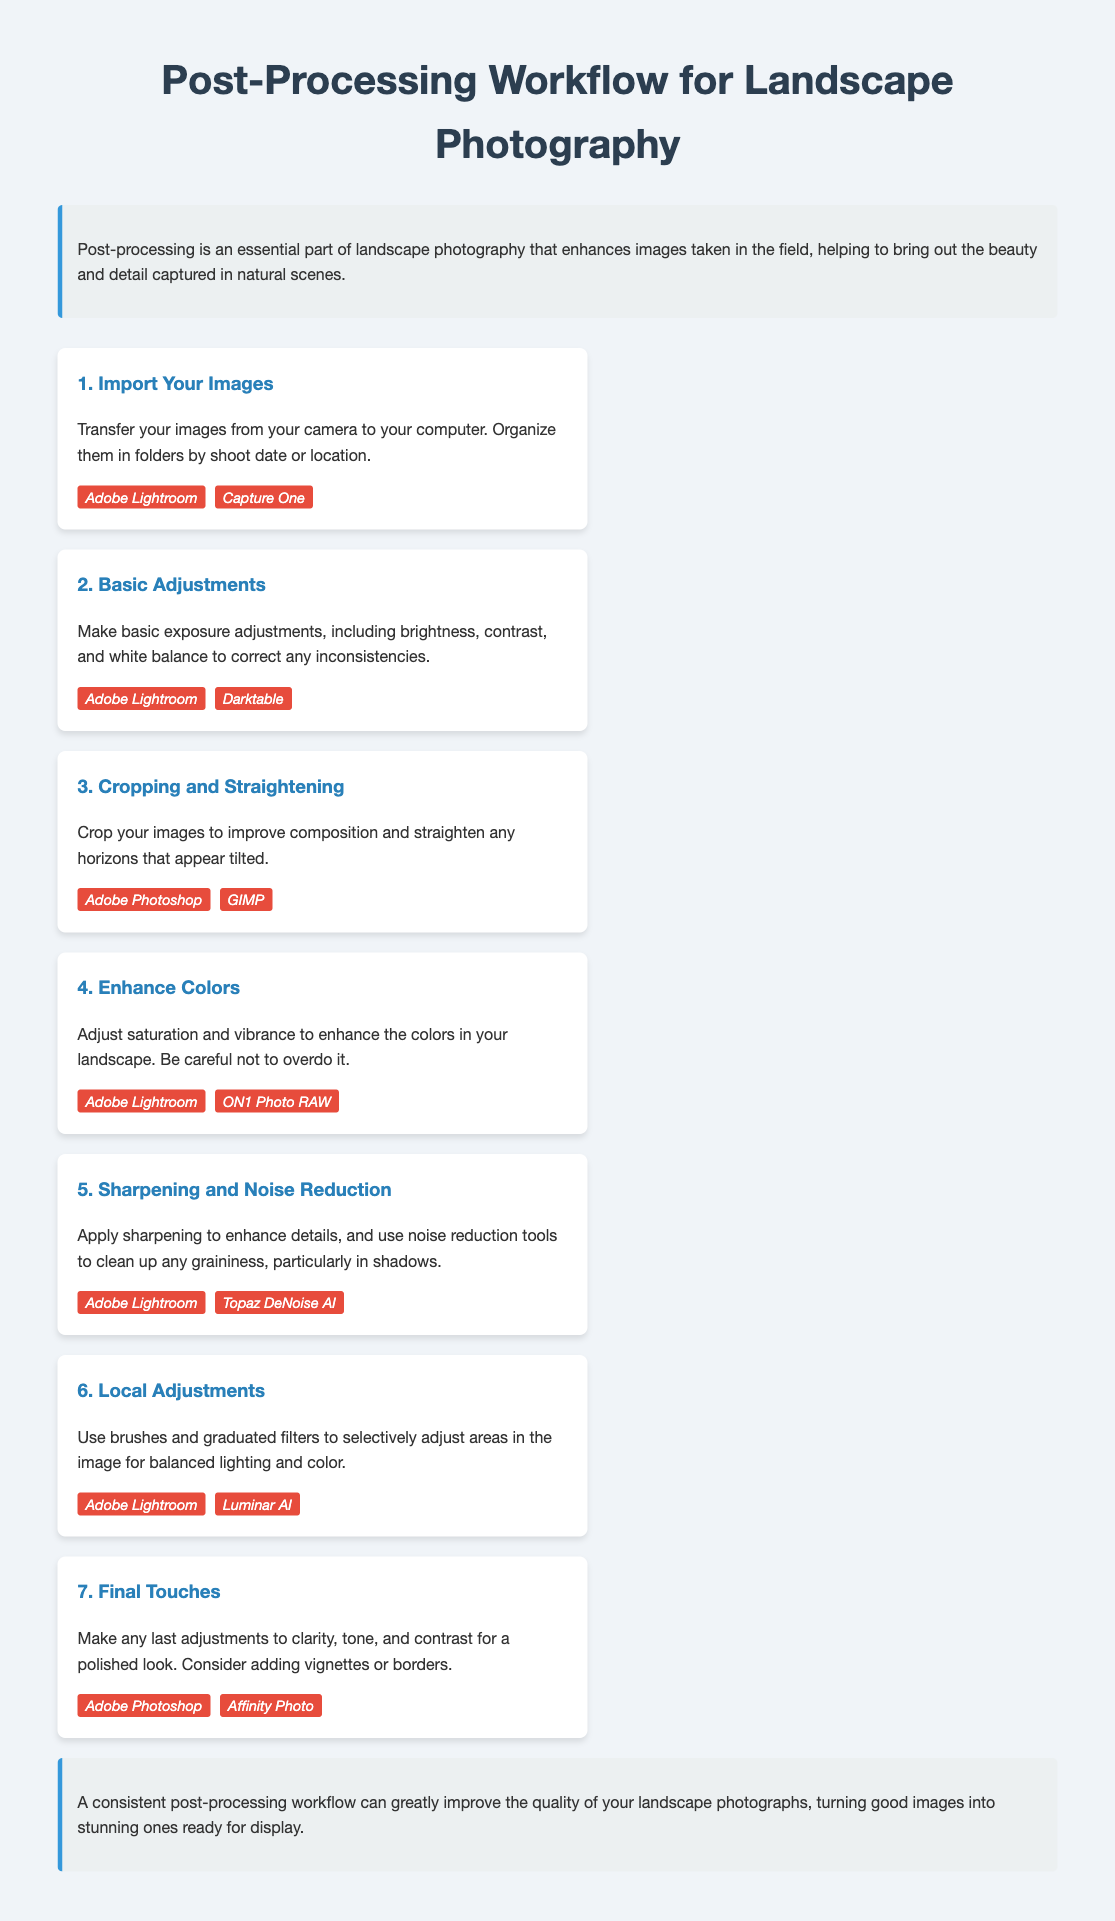what is the first step in the post-processing workflow? The first step is to import your images by transferring them from your camera to your computer.
Answer: Import Your Images which software is suggested for enhancing colors? The software suggested for enhancing colors includes Adobe Lightroom and ON1 Photo RAW.
Answer: Adobe Lightroom, ON1 Photo RAW how many steps are there in the post-processing workflow? The document lists seven distinct steps in the post-processing workflow for landscape photography.
Answer: Seven what type of adjustments are made in step six? In step six, local adjustments are made using brushes and graduated filters.
Answer: Local Adjustments which software is recommended for sharpening and noise reduction? The recommended software for sharpening and noise reduction includes Adobe Lightroom and Topaz DeNoise AI.
Answer: Adobe Lightroom, Topaz DeNoise AI what does the conclusion emphasize? The conclusion emphasizes the importance of a consistent post-processing workflow to improve photo quality.
Answer: A consistent post-processing workflow what is the purpose of cropping and straightening images? The purpose of cropping and straightening images is to improve composition and straighten tilted horizons.
Answer: Improve composition and straighten horizons which software is mentioned for basic adjustments? The software mentioned for basic adjustments includes Adobe Lightroom and Darktable.
Answer: Adobe Lightroom, Darktable 